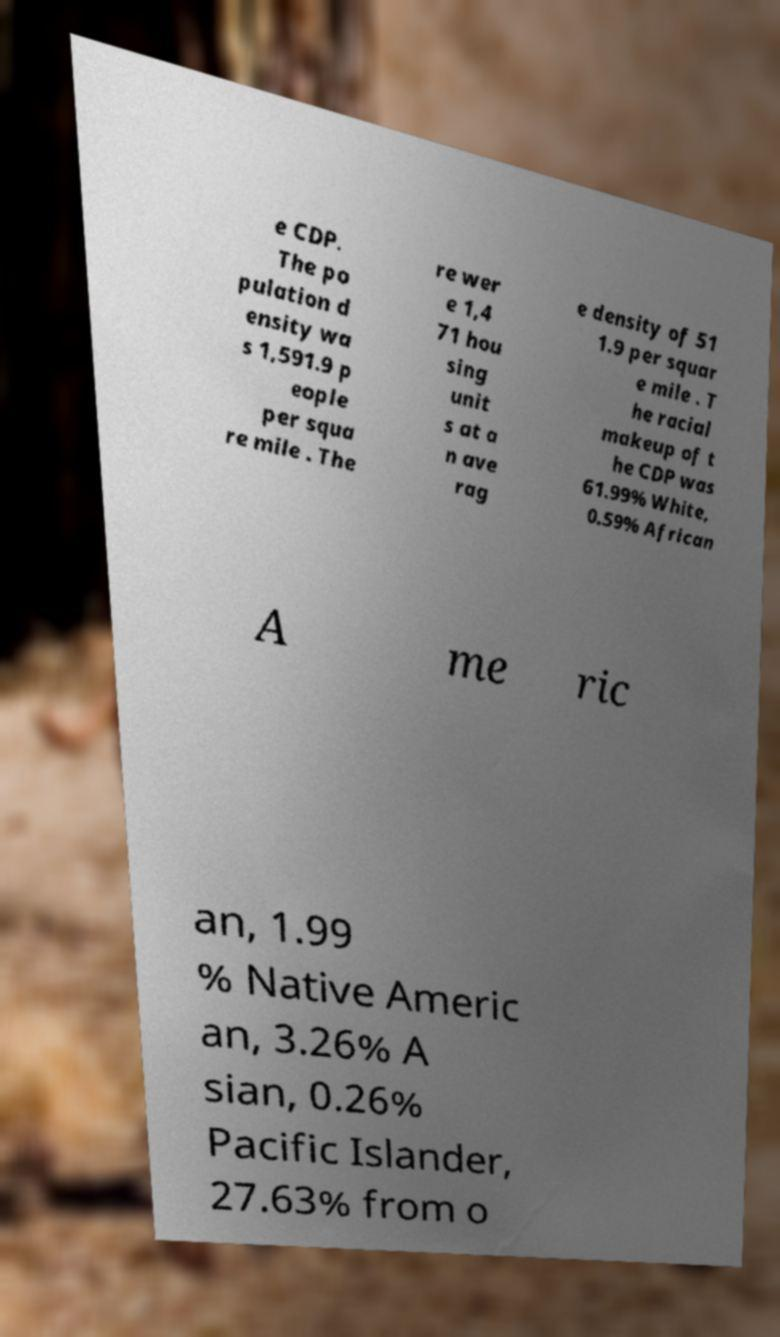There's text embedded in this image that I need extracted. Can you transcribe it verbatim? e CDP. The po pulation d ensity wa s 1,591.9 p eople per squa re mile . The re wer e 1,4 71 hou sing unit s at a n ave rag e density of 51 1.9 per squar e mile . T he racial makeup of t he CDP was 61.99% White, 0.59% African A me ric an, 1.99 % Native Americ an, 3.26% A sian, 0.26% Pacific Islander, 27.63% from o 